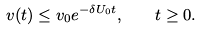<formula> <loc_0><loc_0><loc_500><loc_500>v ( t ) \leq v _ { 0 } e ^ { - \delta U _ { 0 } t } , \quad t \geq 0 .</formula> 